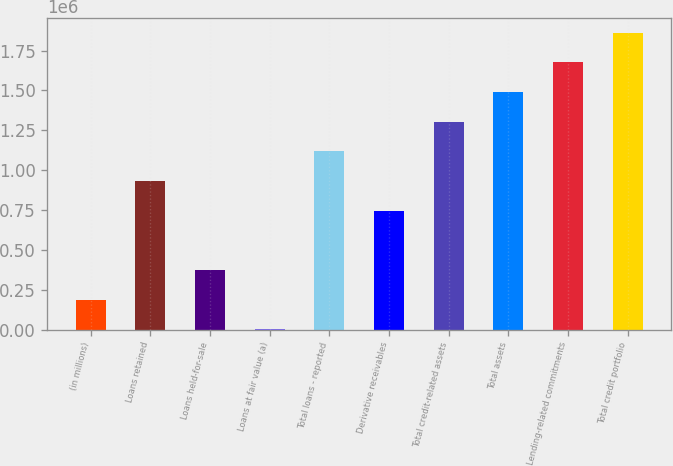<chart> <loc_0><loc_0><loc_500><loc_500><bar_chart><fcel>(in millions)<fcel>Loans retained<fcel>Loans held-for-sale<fcel>Loans at fair value (a)<fcel>Total loans - reported<fcel>Derivative receivables<fcel>Total credit-related assets<fcel>Total assets<fcel>Lending-related commitments<fcel>Total credit portfolio<nl><fcel>188083<fcel>932372<fcel>374155<fcel>2011<fcel>1.11844e+06<fcel>746299<fcel>1.30452e+06<fcel>1.49059e+06<fcel>1.67666e+06<fcel>1.86273e+06<nl></chart> 